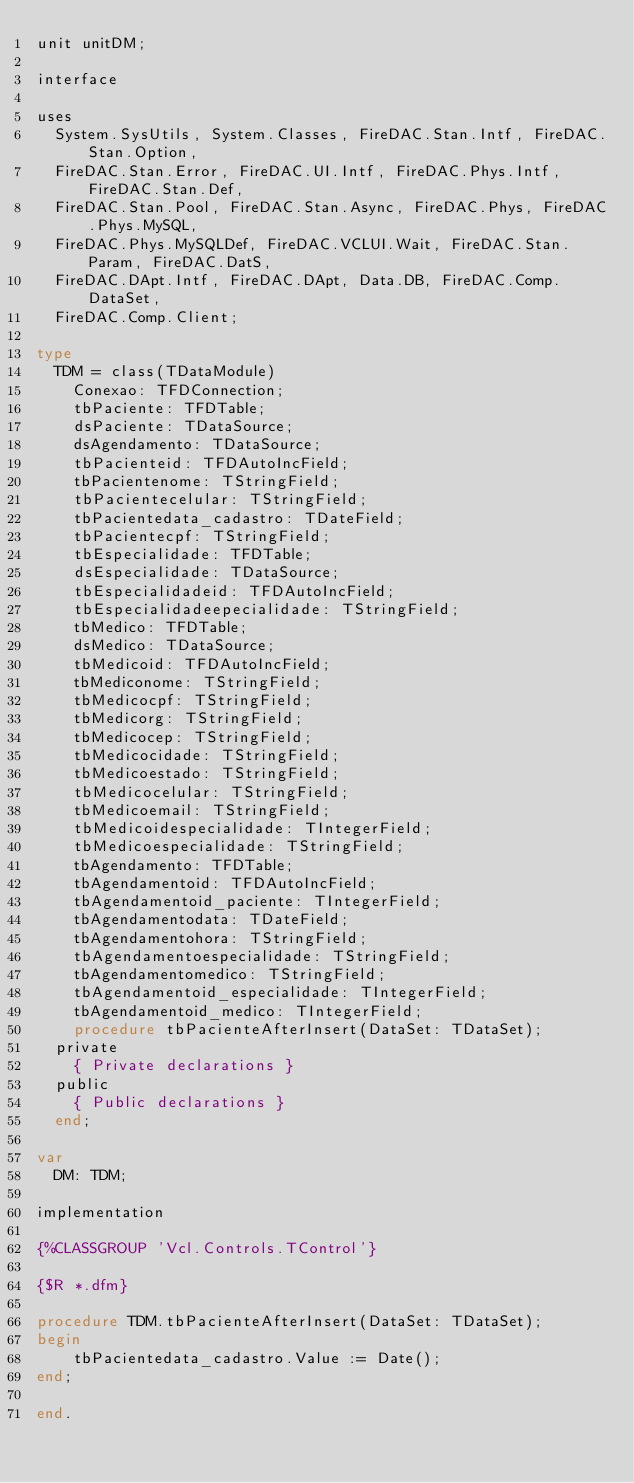<code> <loc_0><loc_0><loc_500><loc_500><_Pascal_>unit unitDM;

interface

uses
  System.SysUtils, System.Classes, FireDAC.Stan.Intf, FireDAC.Stan.Option,
  FireDAC.Stan.Error, FireDAC.UI.Intf, FireDAC.Phys.Intf, FireDAC.Stan.Def,
  FireDAC.Stan.Pool, FireDAC.Stan.Async, FireDAC.Phys, FireDAC.Phys.MySQL,
  FireDAC.Phys.MySQLDef, FireDAC.VCLUI.Wait, FireDAC.Stan.Param, FireDAC.DatS,
  FireDAC.DApt.Intf, FireDAC.DApt, Data.DB, FireDAC.Comp.DataSet,
  FireDAC.Comp.Client;

type
  TDM = class(TDataModule)
    Conexao: TFDConnection;
    tbPaciente: TFDTable;
    dsPaciente: TDataSource;
    dsAgendamento: TDataSource;
    tbPacienteid: TFDAutoIncField;
    tbPacientenome: TStringField;
    tbPacientecelular: TStringField;
    tbPacientedata_cadastro: TDateField;
    tbPacientecpf: TStringField;
    tbEspecialidade: TFDTable;
    dsEspecialidade: TDataSource;
    tbEspecialidadeid: TFDAutoIncField;
    tbEspecialidadeepecialidade: TStringField;
    tbMedico: TFDTable;
    dsMedico: TDataSource;
    tbMedicoid: TFDAutoIncField;
    tbMediconome: TStringField;
    tbMedicocpf: TStringField;
    tbMedicorg: TStringField;
    tbMedicocep: TStringField;
    tbMedicocidade: TStringField;
    tbMedicoestado: TStringField;
    tbMedicocelular: TStringField;
    tbMedicoemail: TStringField;
    tbMedicoidespecialidade: TIntegerField;
    tbMedicoespecialidade: TStringField;
    tbAgendamento: TFDTable;
    tbAgendamentoid: TFDAutoIncField;
    tbAgendamentoid_paciente: TIntegerField;
    tbAgendamentodata: TDateField;
    tbAgendamentohora: TStringField;
    tbAgendamentoespecialidade: TStringField;
    tbAgendamentomedico: TStringField;
    tbAgendamentoid_especialidade: TIntegerField;
    tbAgendamentoid_medico: TIntegerField;
    procedure tbPacienteAfterInsert(DataSet: TDataSet);
  private
    { Private declarations }
  public
    { Public declarations }
  end;

var
  DM: TDM;

implementation

{%CLASSGROUP 'Vcl.Controls.TControl'}

{$R *.dfm}

procedure TDM.tbPacienteAfterInsert(DataSet: TDataSet);
begin
    tbPacientedata_cadastro.Value := Date();
end;

end.
</code> 